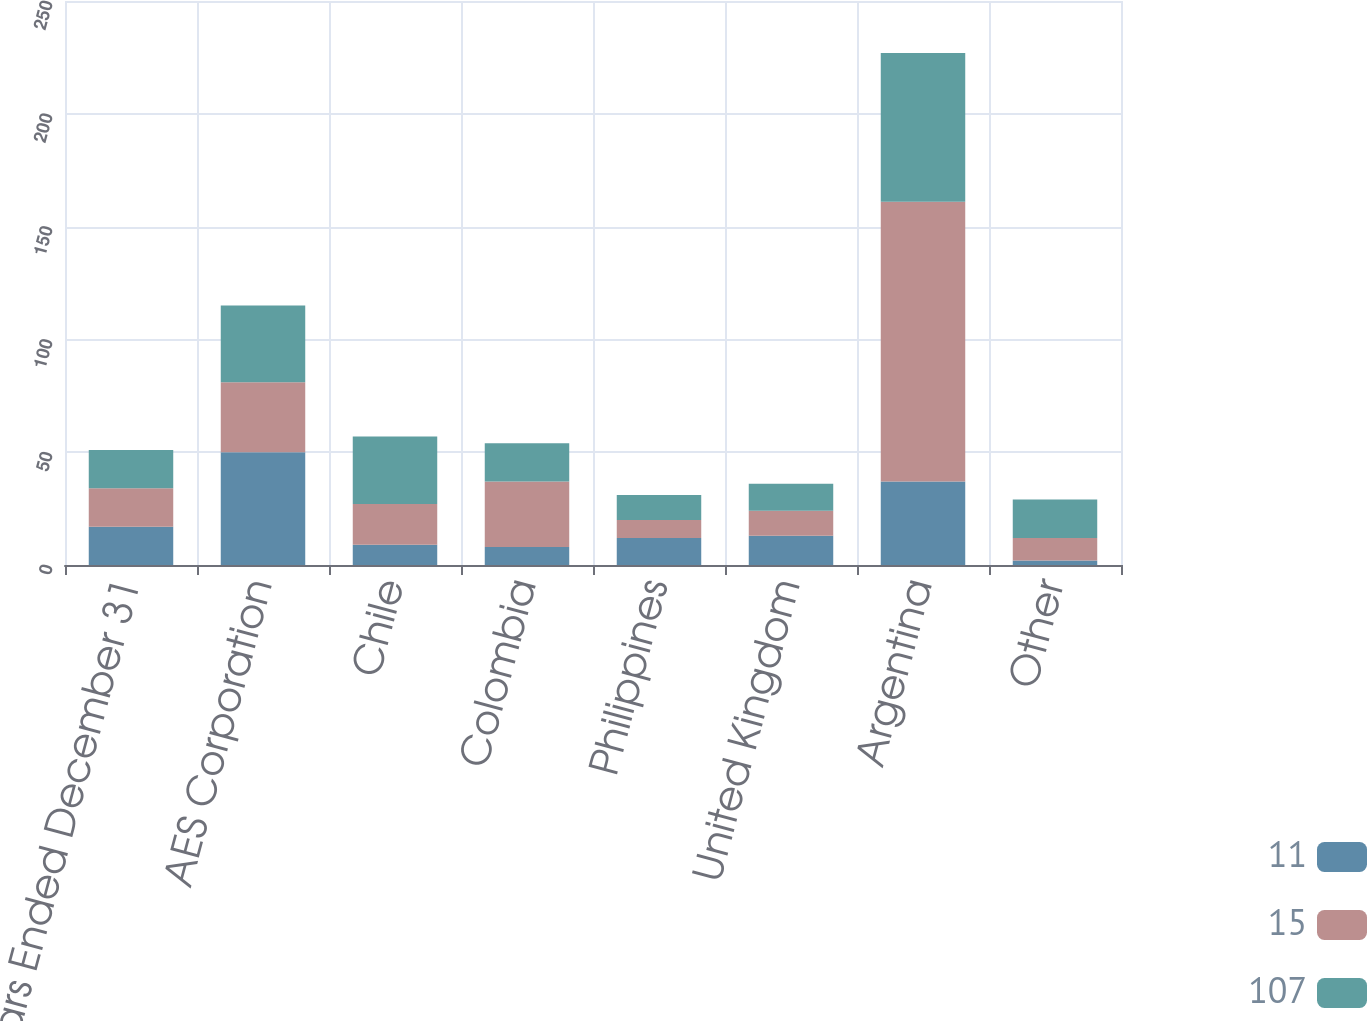<chart> <loc_0><loc_0><loc_500><loc_500><stacked_bar_chart><ecel><fcel>Years Ended December 31<fcel>AES Corporation<fcel>Chile<fcel>Colombia<fcel>Philippines<fcel>United Kingdom<fcel>Argentina<fcel>Other<nl><fcel>11<fcel>17<fcel>50<fcel>9<fcel>8<fcel>12<fcel>13<fcel>37<fcel>2<nl><fcel>15<fcel>17<fcel>31<fcel>18<fcel>29<fcel>8<fcel>11<fcel>124<fcel>10<nl><fcel>107<fcel>17<fcel>34<fcel>30<fcel>17<fcel>11<fcel>12<fcel>66<fcel>17<nl></chart> 